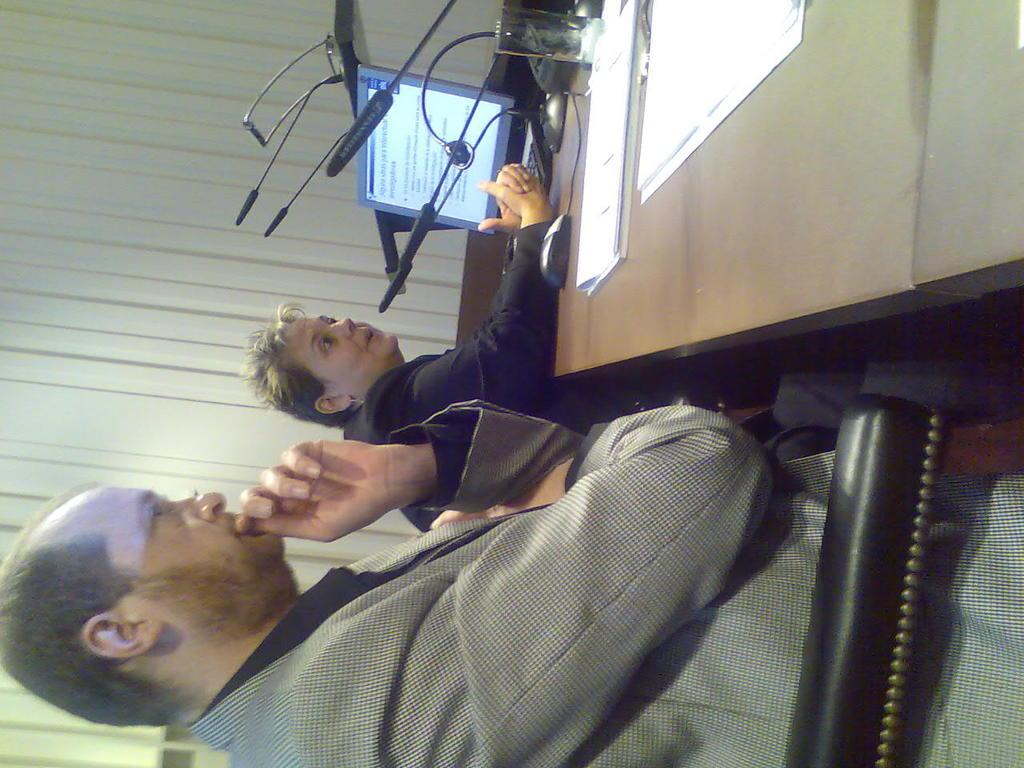How many people are sitting in the image? There are two people sitting on chairs in the image. What is on the table in the image? Papers, a mouse, a keyboard, a system (likely a computer), and microphones (mics) are on the table. What can be seen in the background of the image? There is a white color curtain in the image. Can you tell me how many frogs are on the table in the image? There are no frogs present on the table in the image. What type of care is being provided to the people in the image? There is no indication of any care being provided to the people in the image; they are simply sitting on chairs. 